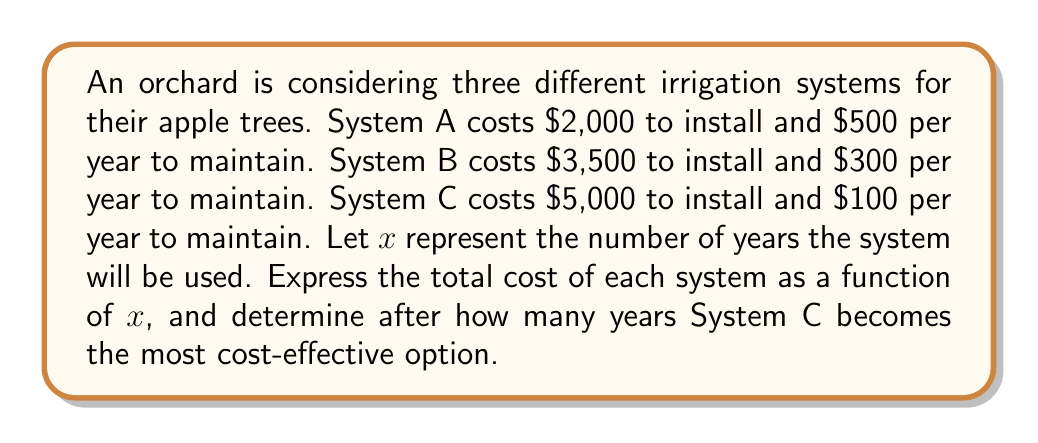What is the answer to this math problem? 1. Express the total cost of each system as a function of $x$:
   System A: $f_A(x) = 2000 + 500x$
   System B: $f_B(x) = 3500 + 300x$
   System C: $f_C(x) = 5000 + 100x$

2. To find when System C becomes the most cost-effective, we need to compare it with both A and B:

   For System C to be more cost-effective than A:
   $f_C(x) < f_A(x)$
   $5000 + 100x < 2000 + 500x$
   $3000 < 400x$
   $x > 7.5$ years

   For System C to be more cost-effective than B:
   $f_C(x) < f_B(x)$
   $5000 + 100x < 3500 + 300x$
   $1500 < 200x$
   $x > 7.5$ years

3. Since both inequalities result in $x > 7.5$, System C becomes the most cost-effective option after 8 years (as we need to use the next whole number after 7.5).
Answer: 8 years 